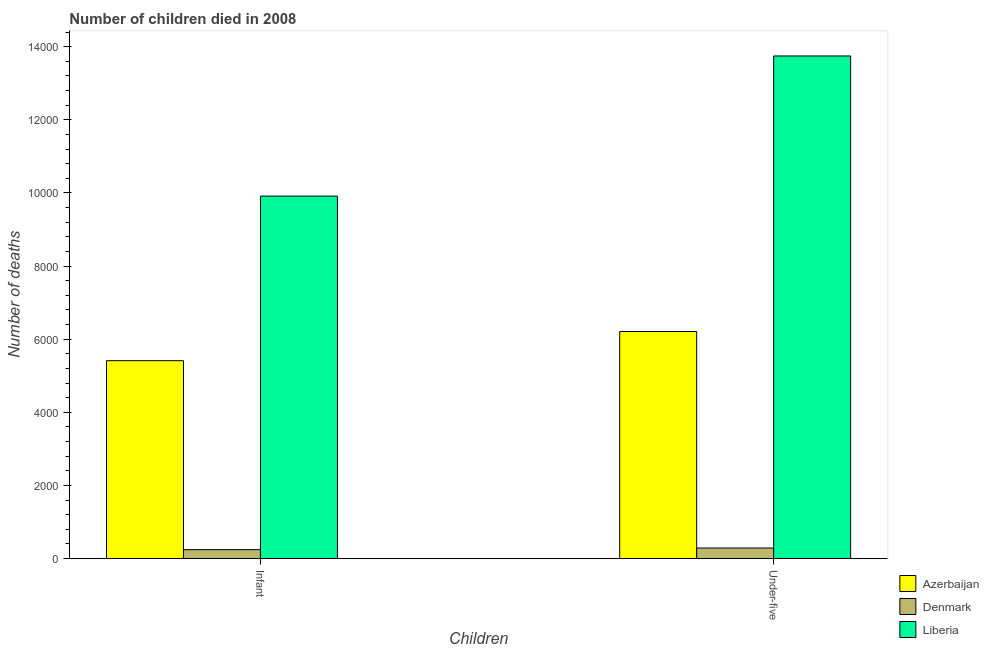How many different coloured bars are there?
Keep it short and to the point. 3. Are the number of bars per tick equal to the number of legend labels?
Offer a terse response. Yes. How many bars are there on the 1st tick from the left?
Keep it short and to the point. 3. What is the label of the 2nd group of bars from the left?
Ensure brevity in your answer.  Under-five. What is the number of infant deaths in Denmark?
Ensure brevity in your answer.  244. Across all countries, what is the maximum number of under-five deaths?
Make the answer very short. 1.37e+04. Across all countries, what is the minimum number of under-five deaths?
Keep it short and to the point. 289. In which country was the number of infant deaths maximum?
Your answer should be very brief. Liberia. What is the total number of infant deaths in the graph?
Offer a very short reply. 1.56e+04. What is the difference between the number of under-five deaths in Denmark and that in Azerbaijan?
Give a very brief answer. -5922. What is the difference between the number of infant deaths in Denmark and the number of under-five deaths in Liberia?
Give a very brief answer. -1.35e+04. What is the average number of under-five deaths per country?
Make the answer very short. 6749.33. What is the difference between the number of infant deaths and number of under-five deaths in Azerbaijan?
Your answer should be very brief. -798. What is the ratio of the number of under-five deaths in Liberia to that in Azerbaijan?
Make the answer very short. 2.21. Is the number of under-five deaths in Denmark less than that in Azerbaijan?
Your answer should be compact. Yes. What does the 1st bar from the left in Infant represents?
Keep it short and to the point. Azerbaijan. How many bars are there?
Offer a terse response. 6. Are the values on the major ticks of Y-axis written in scientific E-notation?
Your response must be concise. No. Does the graph contain grids?
Ensure brevity in your answer.  No. What is the title of the graph?
Your answer should be compact. Number of children died in 2008. What is the label or title of the X-axis?
Offer a very short reply. Children. What is the label or title of the Y-axis?
Your answer should be compact. Number of deaths. What is the Number of deaths of Azerbaijan in Infant?
Offer a very short reply. 5413. What is the Number of deaths of Denmark in Infant?
Offer a very short reply. 244. What is the Number of deaths in Liberia in Infant?
Your answer should be compact. 9915. What is the Number of deaths of Azerbaijan in Under-five?
Offer a terse response. 6211. What is the Number of deaths of Denmark in Under-five?
Offer a terse response. 289. What is the Number of deaths in Liberia in Under-five?
Offer a very short reply. 1.37e+04. Across all Children, what is the maximum Number of deaths of Azerbaijan?
Provide a short and direct response. 6211. Across all Children, what is the maximum Number of deaths in Denmark?
Provide a short and direct response. 289. Across all Children, what is the maximum Number of deaths in Liberia?
Your answer should be compact. 1.37e+04. Across all Children, what is the minimum Number of deaths of Azerbaijan?
Provide a short and direct response. 5413. Across all Children, what is the minimum Number of deaths in Denmark?
Ensure brevity in your answer.  244. Across all Children, what is the minimum Number of deaths in Liberia?
Provide a succinct answer. 9915. What is the total Number of deaths in Azerbaijan in the graph?
Your answer should be very brief. 1.16e+04. What is the total Number of deaths of Denmark in the graph?
Provide a short and direct response. 533. What is the total Number of deaths of Liberia in the graph?
Your answer should be compact. 2.37e+04. What is the difference between the Number of deaths of Azerbaijan in Infant and that in Under-five?
Your response must be concise. -798. What is the difference between the Number of deaths of Denmark in Infant and that in Under-five?
Your response must be concise. -45. What is the difference between the Number of deaths of Liberia in Infant and that in Under-five?
Offer a terse response. -3833. What is the difference between the Number of deaths in Azerbaijan in Infant and the Number of deaths in Denmark in Under-five?
Ensure brevity in your answer.  5124. What is the difference between the Number of deaths of Azerbaijan in Infant and the Number of deaths of Liberia in Under-five?
Provide a succinct answer. -8335. What is the difference between the Number of deaths in Denmark in Infant and the Number of deaths in Liberia in Under-five?
Your response must be concise. -1.35e+04. What is the average Number of deaths in Azerbaijan per Children?
Keep it short and to the point. 5812. What is the average Number of deaths of Denmark per Children?
Your response must be concise. 266.5. What is the average Number of deaths of Liberia per Children?
Give a very brief answer. 1.18e+04. What is the difference between the Number of deaths of Azerbaijan and Number of deaths of Denmark in Infant?
Ensure brevity in your answer.  5169. What is the difference between the Number of deaths in Azerbaijan and Number of deaths in Liberia in Infant?
Give a very brief answer. -4502. What is the difference between the Number of deaths of Denmark and Number of deaths of Liberia in Infant?
Offer a very short reply. -9671. What is the difference between the Number of deaths in Azerbaijan and Number of deaths in Denmark in Under-five?
Give a very brief answer. 5922. What is the difference between the Number of deaths of Azerbaijan and Number of deaths of Liberia in Under-five?
Your response must be concise. -7537. What is the difference between the Number of deaths in Denmark and Number of deaths in Liberia in Under-five?
Your answer should be very brief. -1.35e+04. What is the ratio of the Number of deaths in Azerbaijan in Infant to that in Under-five?
Offer a very short reply. 0.87. What is the ratio of the Number of deaths in Denmark in Infant to that in Under-five?
Your response must be concise. 0.84. What is the ratio of the Number of deaths in Liberia in Infant to that in Under-five?
Offer a very short reply. 0.72. What is the difference between the highest and the second highest Number of deaths of Azerbaijan?
Your answer should be compact. 798. What is the difference between the highest and the second highest Number of deaths in Denmark?
Your answer should be very brief. 45. What is the difference between the highest and the second highest Number of deaths in Liberia?
Make the answer very short. 3833. What is the difference between the highest and the lowest Number of deaths of Azerbaijan?
Provide a succinct answer. 798. What is the difference between the highest and the lowest Number of deaths of Liberia?
Provide a short and direct response. 3833. 